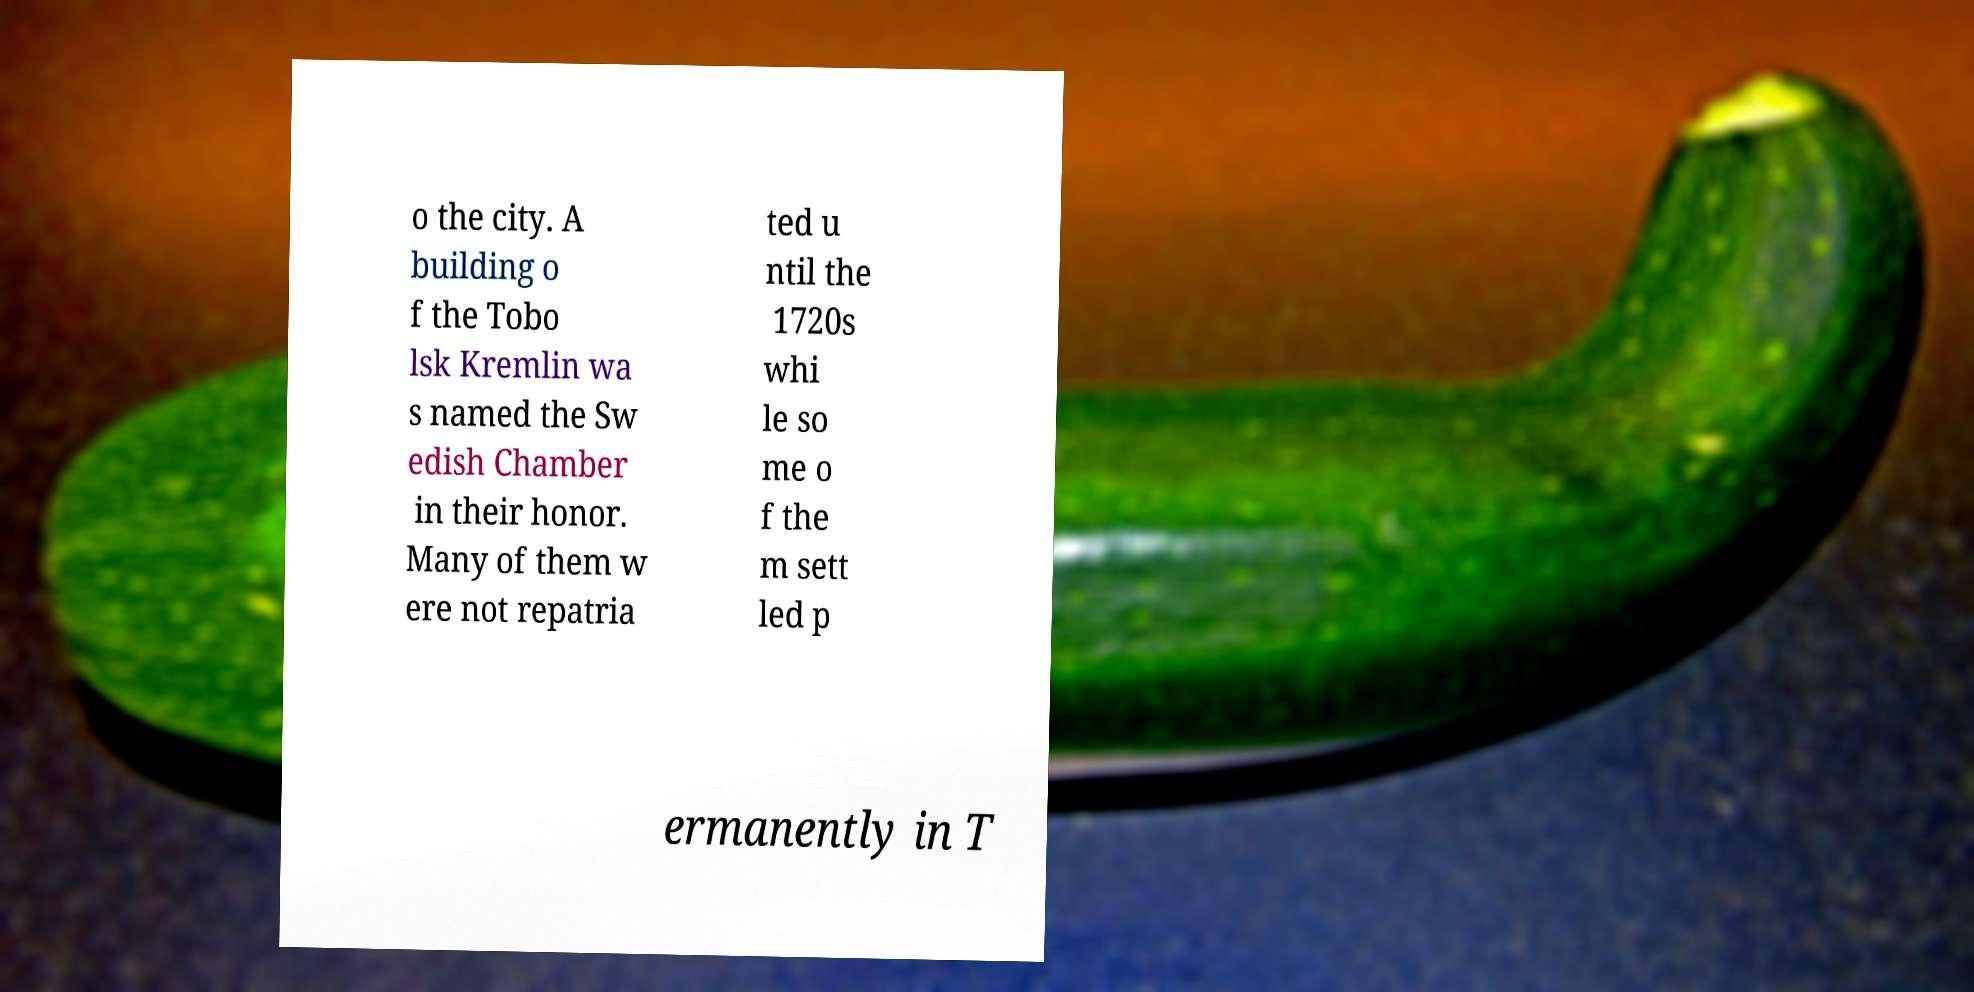Could you assist in decoding the text presented in this image and type it out clearly? o the city. A building o f the Tobo lsk Kremlin wa s named the Sw edish Chamber in their honor. Many of them w ere not repatria ted u ntil the 1720s whi le so me o f the m sett led p ermanently in T 